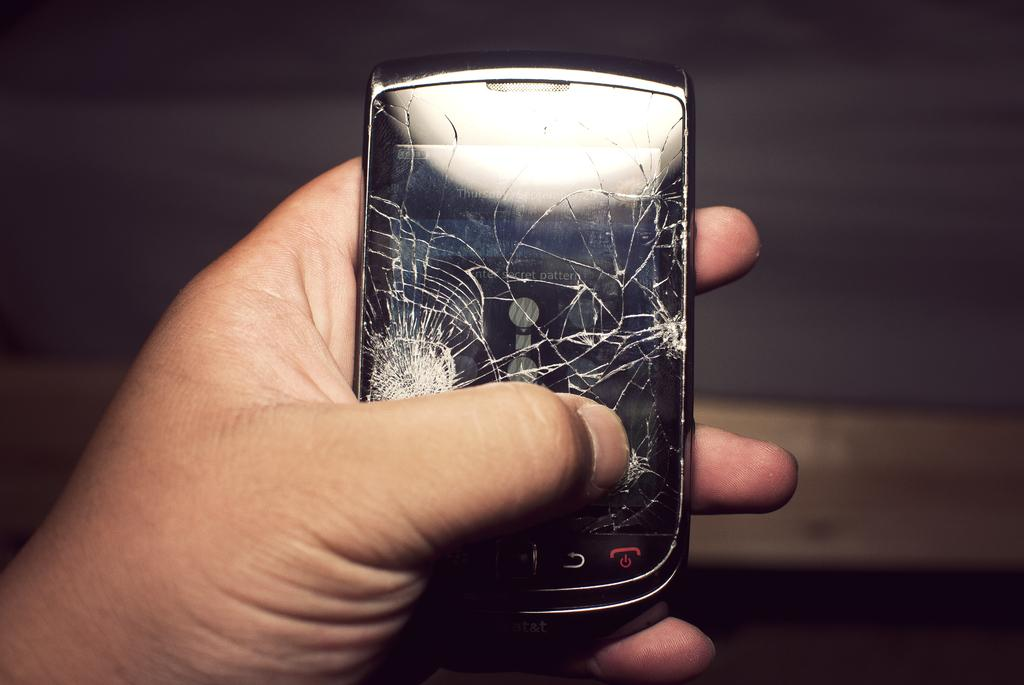What is the person holding in the image? There is a person's hand holding a mobile phone in the image. Can you describe the background of the image? The background of the image is blurred. How many balls are visible in the image? There are no balls visible in the image. What type of pet is present in the image? There is no pet present in the image. 